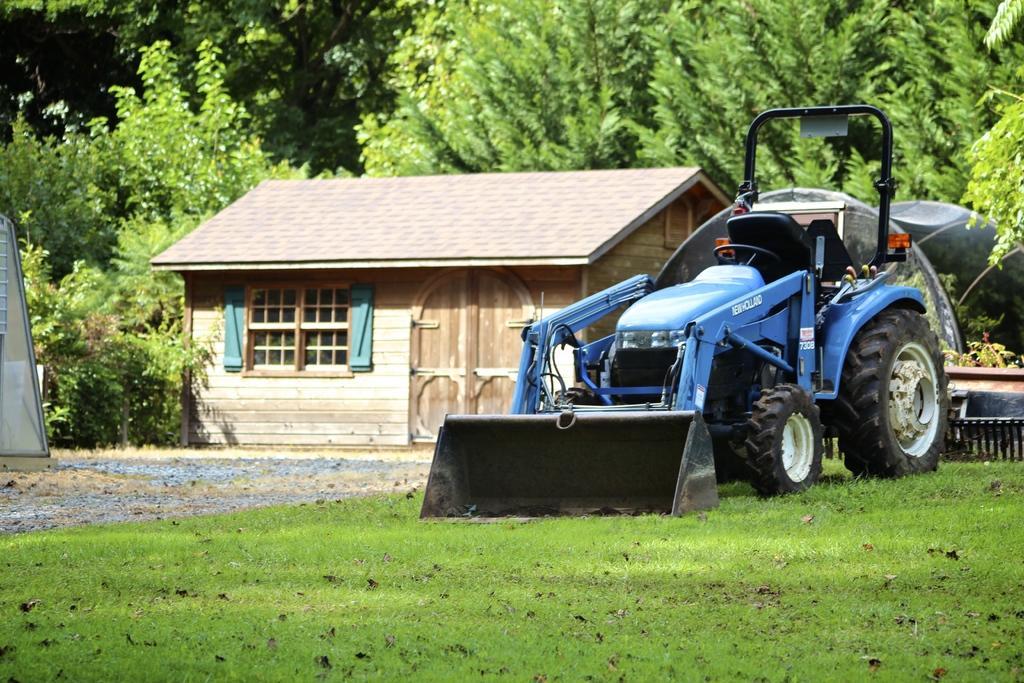Could you give a brief overview of what you see in this image? This image consists of a vehicle in blue color. At the bottom, there is green grass on the ground. In the front, we can see a small house made up of wood along with a door and a window. In the background, there are many trees. On the right, we can see a small fence. 